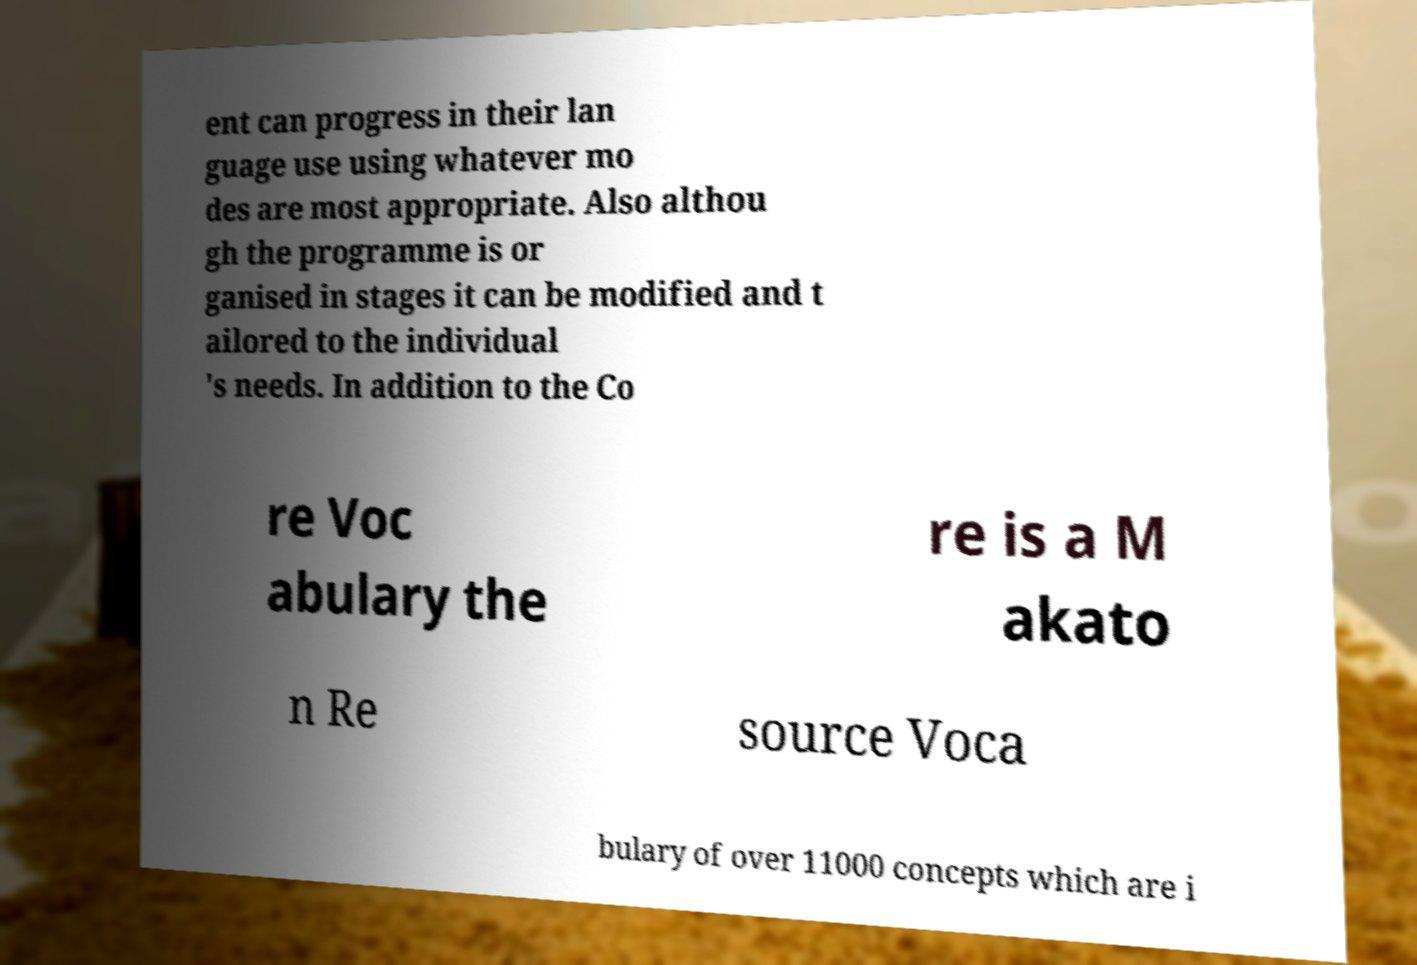Please read and relay the text visible in this image. What does it say? ent can progress in their lan guage use using whatever mo des are most appropriate. Also althou gh the programme is or ganised in stages it can be modified and t ailored to the individual 's needs. In addition to the Co re Voc abulary the re is a M akato n Re source Voca bulary of over 11000 concepts which are i 